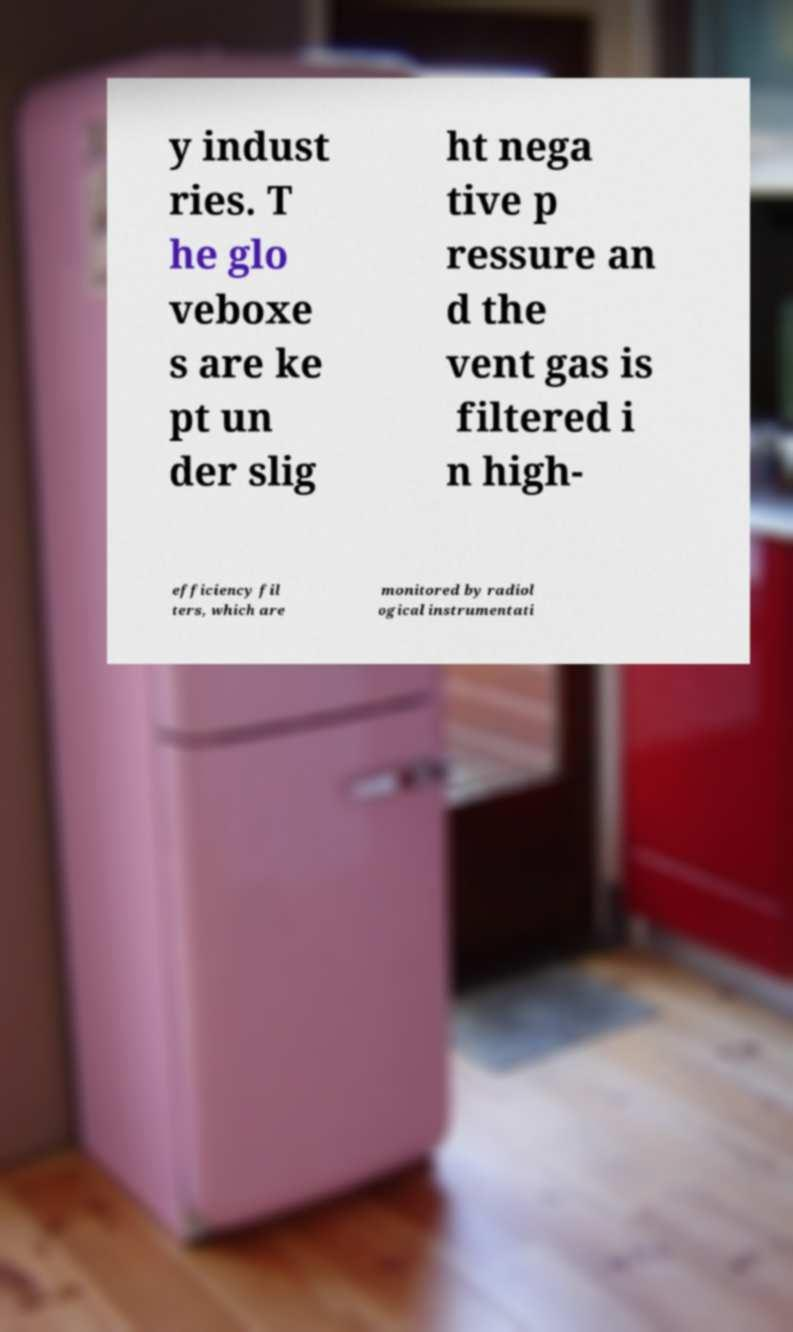What messages or text are displayed in this image? I need them in a readable, typed format. y indust ries. T he glo veboxe s are ke pt un der slig ht nega tive p ressure an d the vent gas is filtered i n high- efficiency fil ters, which are monitored by radiol ogical instrumentati 